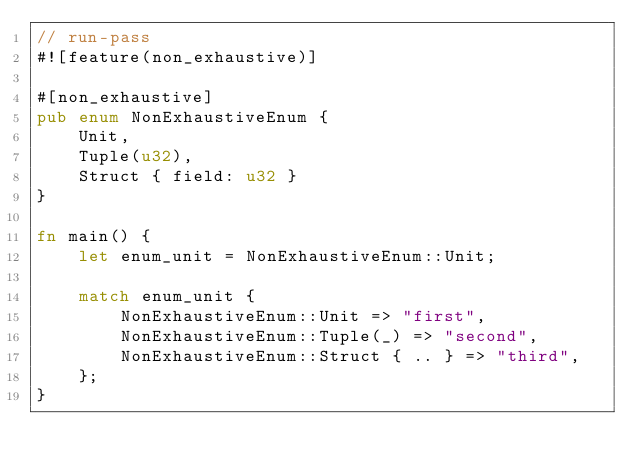<code> <loc_0><loc_0><loc_500><loc_500><_Rust_>// run-pass
#![feature(non_exhaustive)]

#[non_exhaustive]
pub enum NonExhaustiveEnum {
    Unit,
    Tuple(u32),
    Struct { field: u32 }
}

fn main() {
    let enum_unit = NonExhaustiveEnum::Unit;

    match enum_unit {
        NonExhaustiveEnum::Unit => "first",
        NonExhaustiveEnum::Tuple(_) => "second",
        NonExhaustiveEnum::Struct { .. } => "third",
    };
}
</code> 